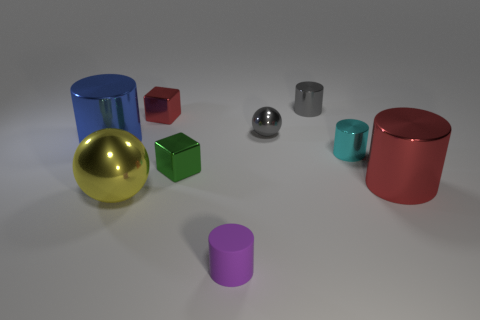Subtract 1 cylinders. How many cylinders are left? 4 Subtract all red cylinders. Subtract all blue balls. How many cylinders are left? 4 Add 1 red metal blocks. How many objects exist? 10 Subtract all blocks. How many objects are left? 7 Subtract all yellow metal spheres. Subtract all gray spheres. How many objects are left? 7 Add 8 purple rubber cylinders. How many purple rubber cylinders are left? 9 Add 2 small gray shiny things. How many small gray shiny things exist? 4 Subtract 0 purple balls. How many objects are left? 9 